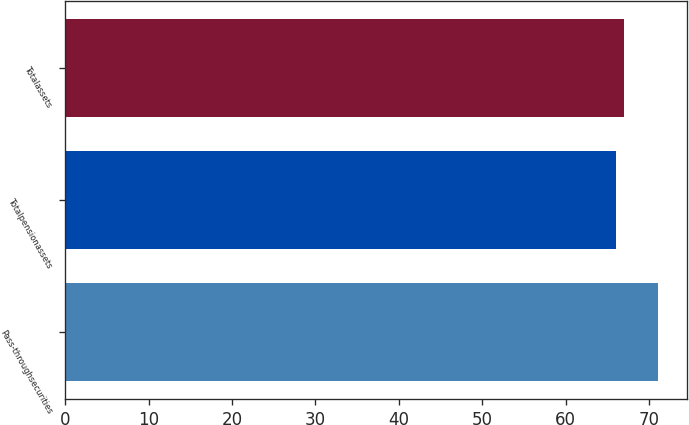Convert chart. <chart><loc_0><loc_0><loc_500><loc_500><bar_chart><fcel>Pass-throughsecurities<fcel>Totalpensionassets<fcel>Totalassets<nl><fcel>71<fcel>66<fcel>67<nl></chart> 